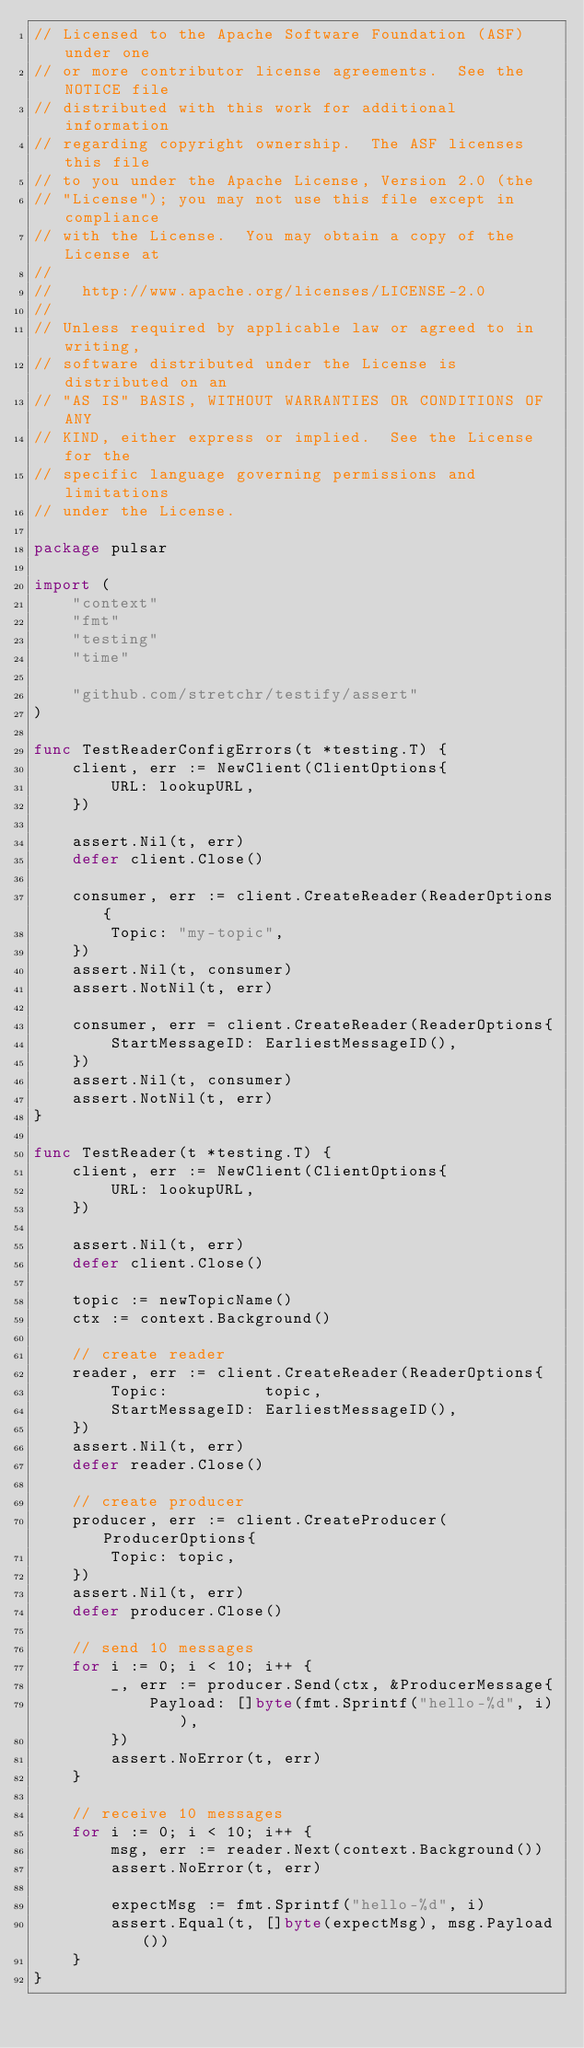Convert code to text. <code><loc_0><loc_0><loc_500><loc_500><_Go_>// Licensed to the Apache Software Foundation (ASF) under one
// or more contributor license agreements.  See the NOTICE file
// distributed with this work for additional information
// regarding copyright ownership.  The ASF licenses this file
// to you under the Apache License, Version 2.0 (the
// "License"); you may not use this file except in compliance
// with the License.  You may obtain a copy of the License at
//
//   http://www.apache.org/licenses/LICENSE-2.0
//
// Unless required by applicable law or agreed to in writing,
// software distributed under the License is distributed on an
// "AS IS" BASIS, WITHOUT WARRANTIES OR CONDITIONS OF ANY
// KIND, either express or implied.  See the License for the
// specific language governing permissions and limitations
// under the License.

package pulsar

import (
	"context"
	"fmt"
	"testing"
	"time"

	"github.com/stretchr/testify/assert"
)

func TestReaderConfigErrors(t *testing.T) {
	client, err := NewClient(ClientOptions{
		URL: lookupURL,
	})

	assert.Nil(t, err)
	defer client.Close()

	consumer, err := client.CreateReader(ReaderOptions{
		Topic: "my-topic",
	})
	assert.Nil(t, consumer)
	assert.NotNil(t, err)

	consumer, err = client.CreateReader(ReaderOptions{
		StartMessageID: EarliestMessageID(),
	})
	assert.Nil(t, consumer)
	assert.NotNil(t, err)
}

func TestReader(t *testing.T) {
	client, err := NewClient(ClientOptions{
		URL: lookupURL,
	})

	assert.Nil(t, err)
	defer client.Close()

	topic := newTopicName()
	ctx := context.Background()

	// create reader
	reader, err := client.CreateReader(ReaderOptions{
		Topic:          topic,
		StartMessageID: EarliestMessageID(),
	})
	assert.Nil(t, err)
	defer reader.Close()

	// create producer
	producer, err := client.CreateProducer(ProducerOptions{
		Topic: topic,
	})
	assert.Nil(t, err)
	defer producer.Close()

	// send 10 messages
	for i := 0; i < 10; i++ {
		_, err := producer.Send(ctx, &ProducerMessage{
			Payload: []byte(fmt.Sprintf("hello-%d", i)),
		})
		assert.NoError(t, err)
	}

	// receive 10 messages
	for i := 0; i < 10; i++ {
		msg, err := reader.Next(context.Background())
		assert.NoError(t, err)

		expectMsg := fmt.Sprintf("hello-%d", i)
		assert.Equal(t, []byte(expectMsg), msg.Payload())
	}
}
</code> 